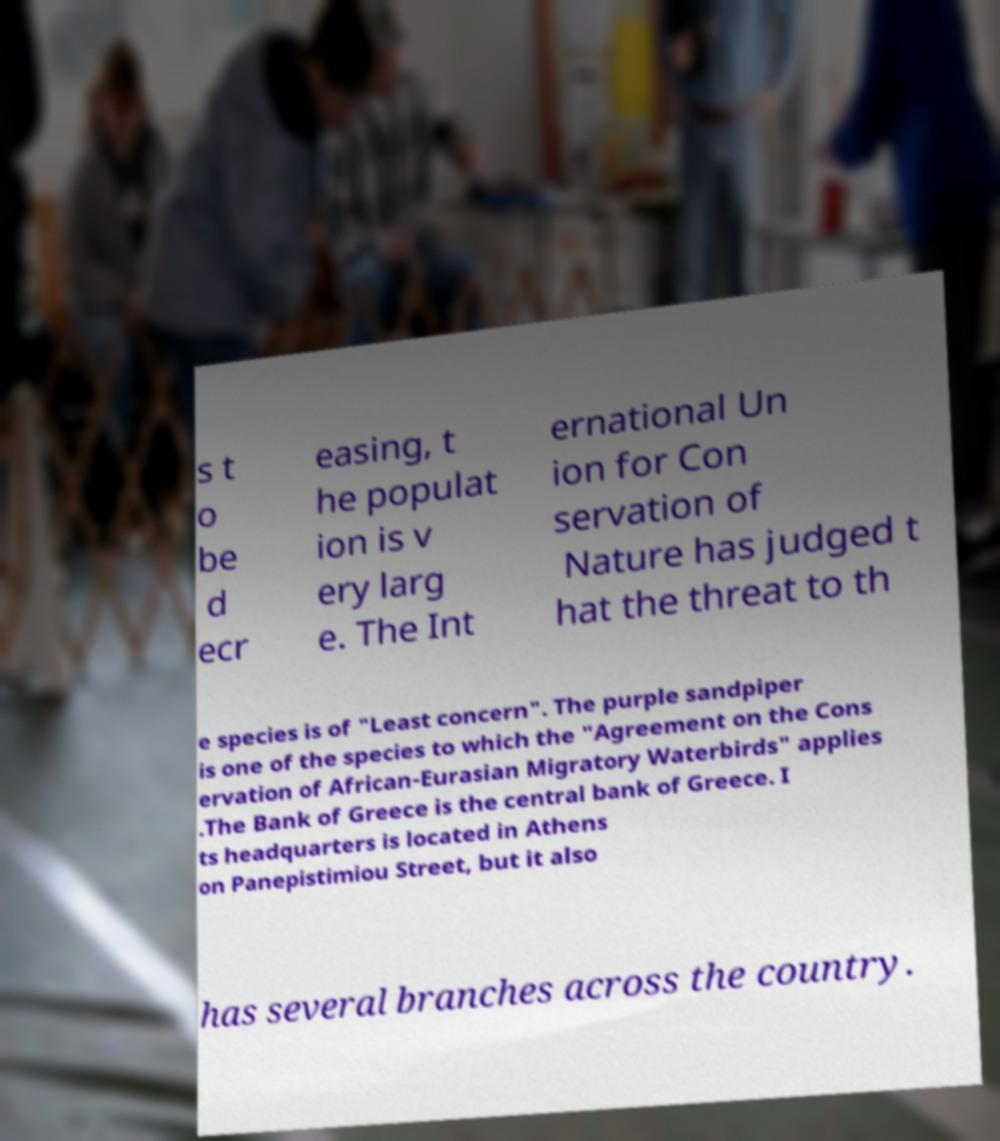Can you read and provide the text displayed in the image?This photo seems to have some interesting text. Can you extract and type it out for me? s t o be d ecr easing, t he populat ion is v ery larg e. The Int ernational Un ion for Con servation of Nature has judged t hat the threat to th e species is of "Least concern". The purple sandpiper is one of the species to which the "Agreement on the Cons ervation of African-Eurasian Migratory Waterbirds" applies .The Bank of Greece is the central bank of Greece. I ts headquarters is located in Athens on Panepistimiou Street, but it also has several branches across the country. 